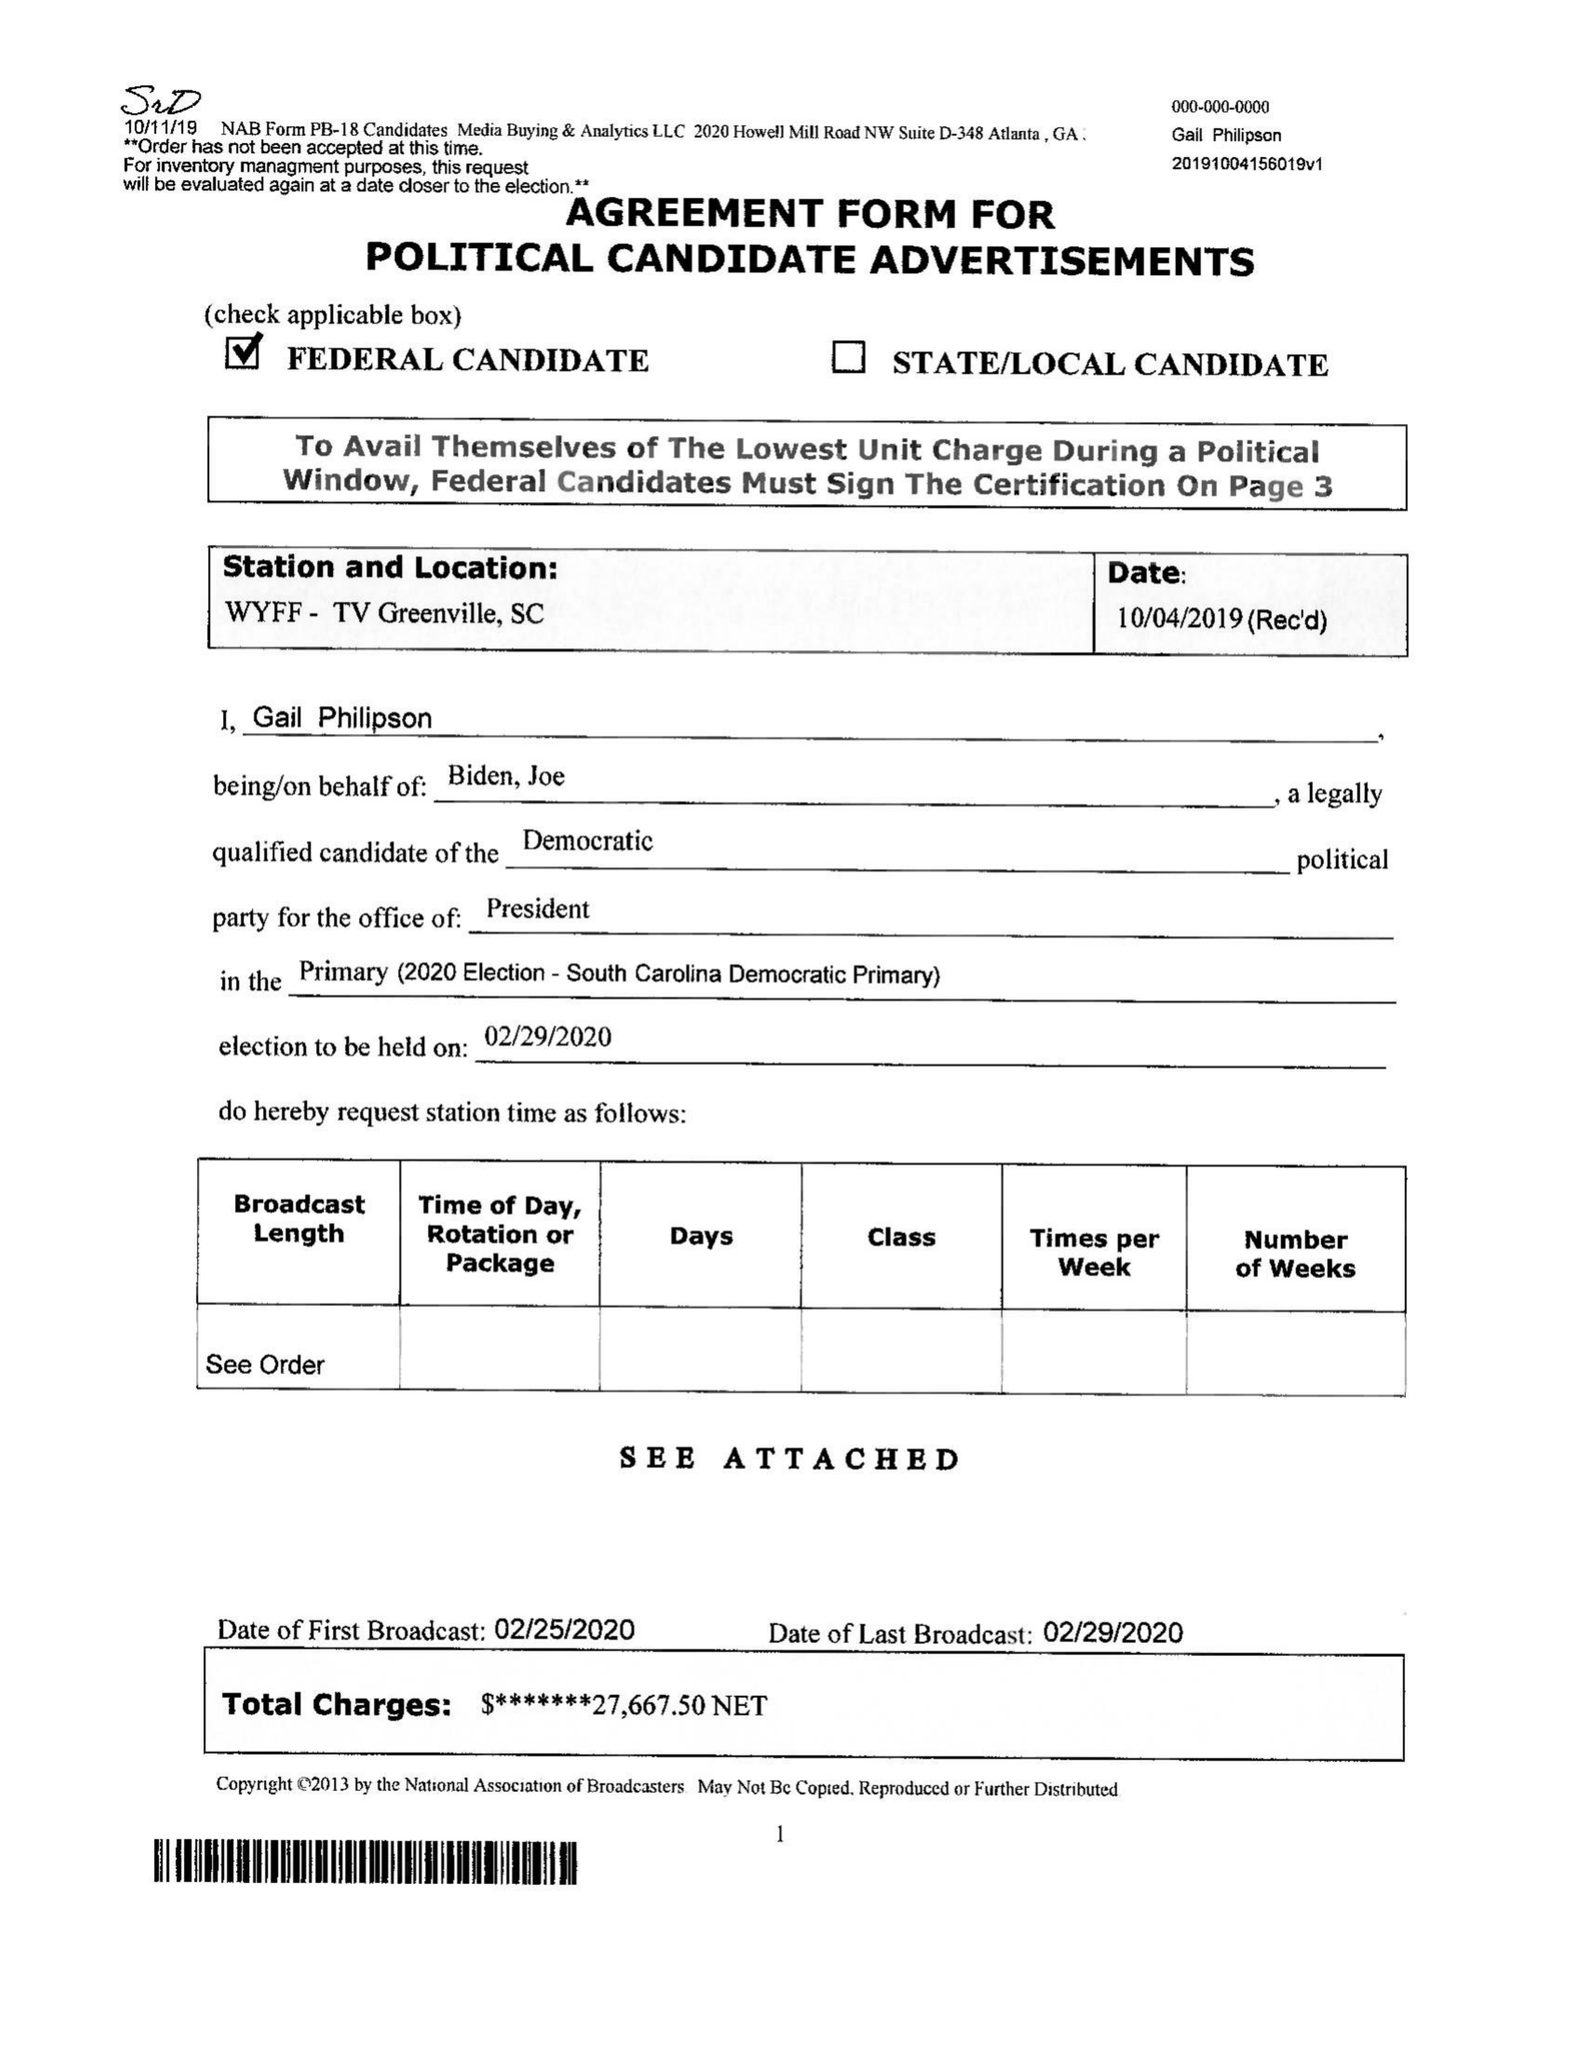What is the value for the gross_amount?
Answer the question using a single word or phrase. None 